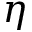Convert formula to latex. <formula><loc_0><loc_0><loc_500><loc_500>\eta</formula> 